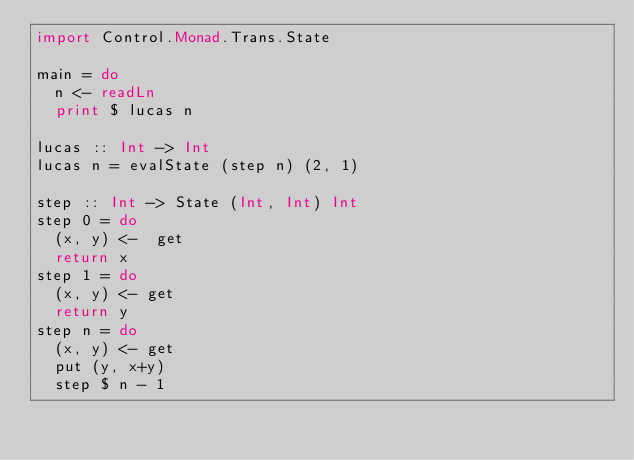<code> <loc_0><loc_0><loc_500><loc_500><_Haskell_>import Control.Monad.Trans.State
 
main = do
  n <- readLn
  print $ lucas n
 
lucas :: Int -> Int
lucas n = evalState (step n) (2, 1)
 
step :: Int -> State (Int, Int) Int
step 0 = do
  (x, y) <-  get
  return x
step 1 = do
  (x, y) <- get
  return y
step n = do
  (x, y) <- get
  put (y, x+y)
  step $ n - 1</code> 